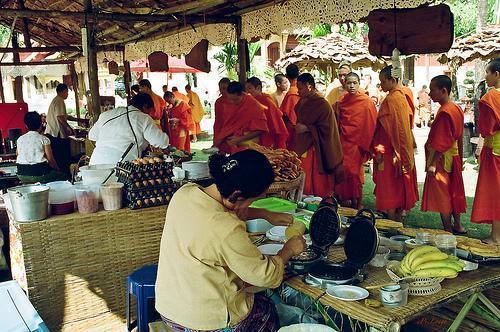How many waffle irons?
Give a very brief answer. 2. How many egg crates are there?
Give a very brief answer. 5. 